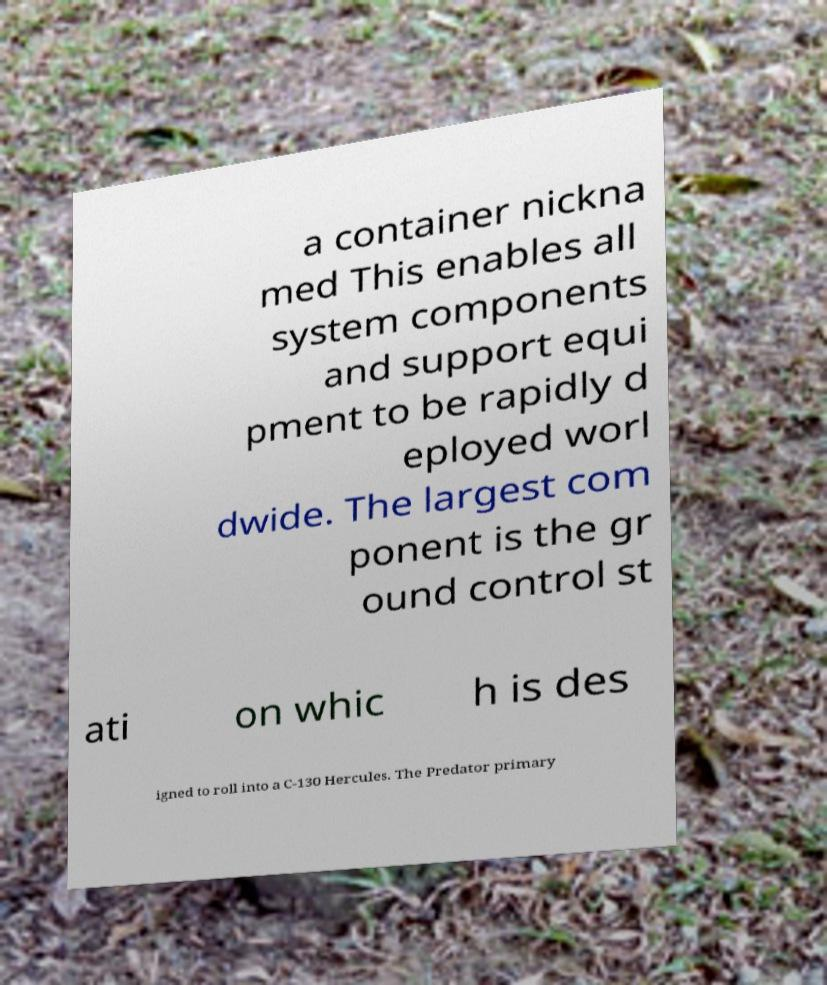Can you accurately transcribe the text from the provided image for me? a container nickna med This enables all system components and support equi pment to be rapidly d eployed worl dwide. The largest com ponent is the gr ound control st ati on whic h is des igned to roll into a C-130 Hercules. The Predator primary 